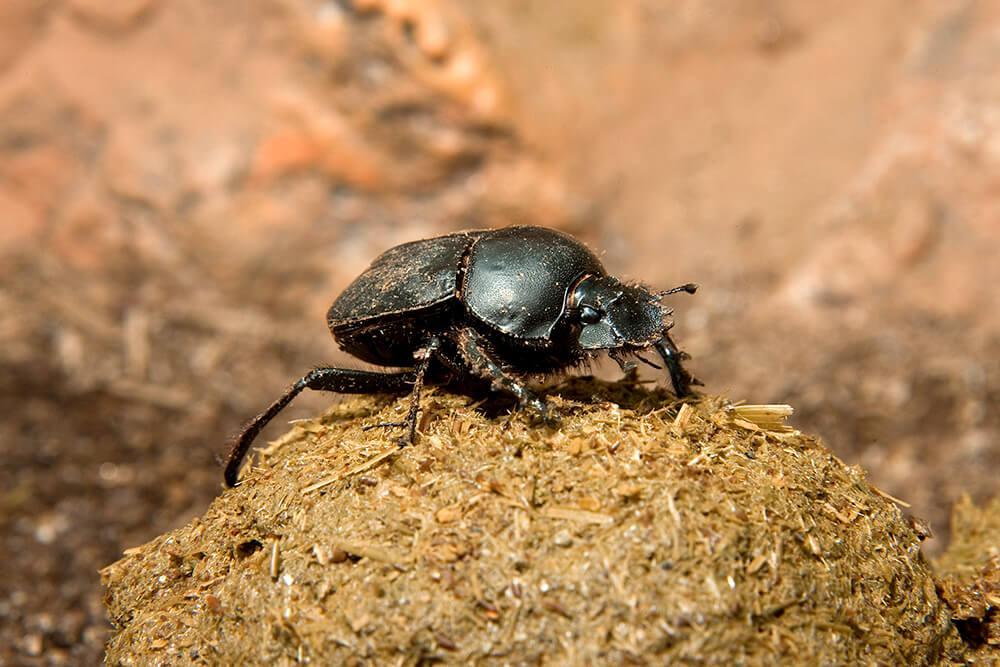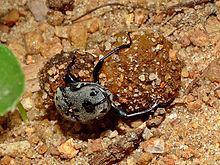The first image is the image on the left, the second image is the image on the right. Assess this claim about the two images: "An image includes one dung ball and two beetles.". Correct or not? Answer yes or no. No. The first image is the image on the left, the second image is the image on the right. Assess this claim about the two images: "There are 3 beetles present near a dung ball.". Correct or not? Answer yes or no. No. 